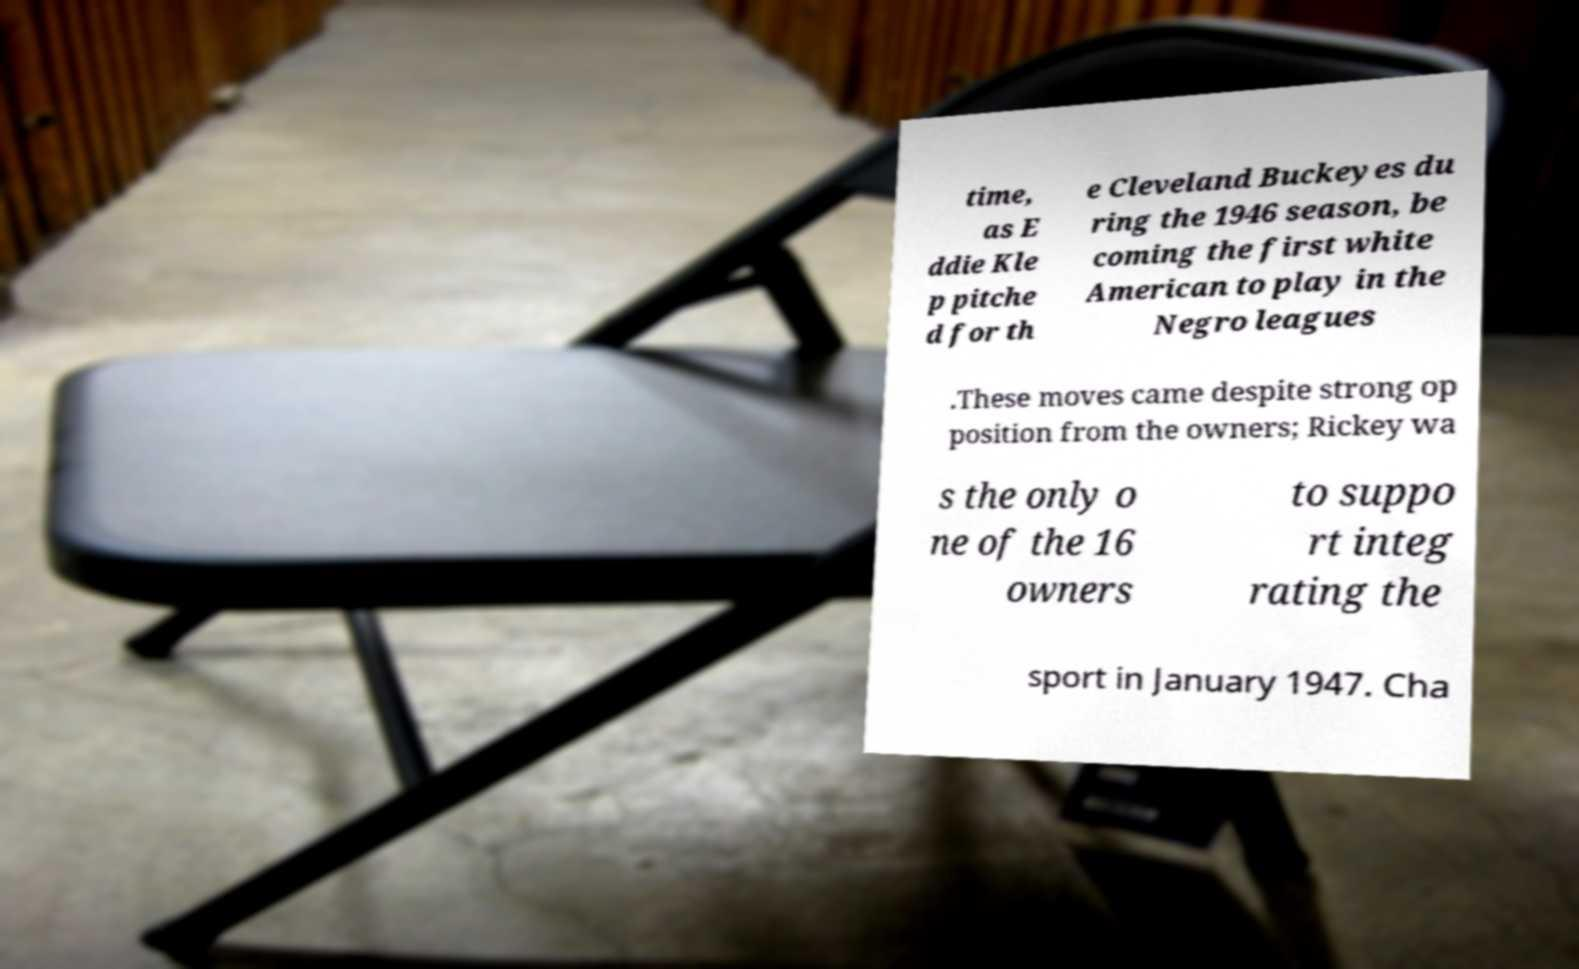Could you assist in decoding the text presented in this image and type it out clearly? time, as E ddie Kle p pitche d for th e Cleveland Buckeyes du ring the 1946 season, be coming the first white American to play in the Negro leagues .These moves came despite strong op position from the owners; Rickey wa s the only o ne of the 16 owners to suppo rt integ rating the sport in January 1947. Cha 